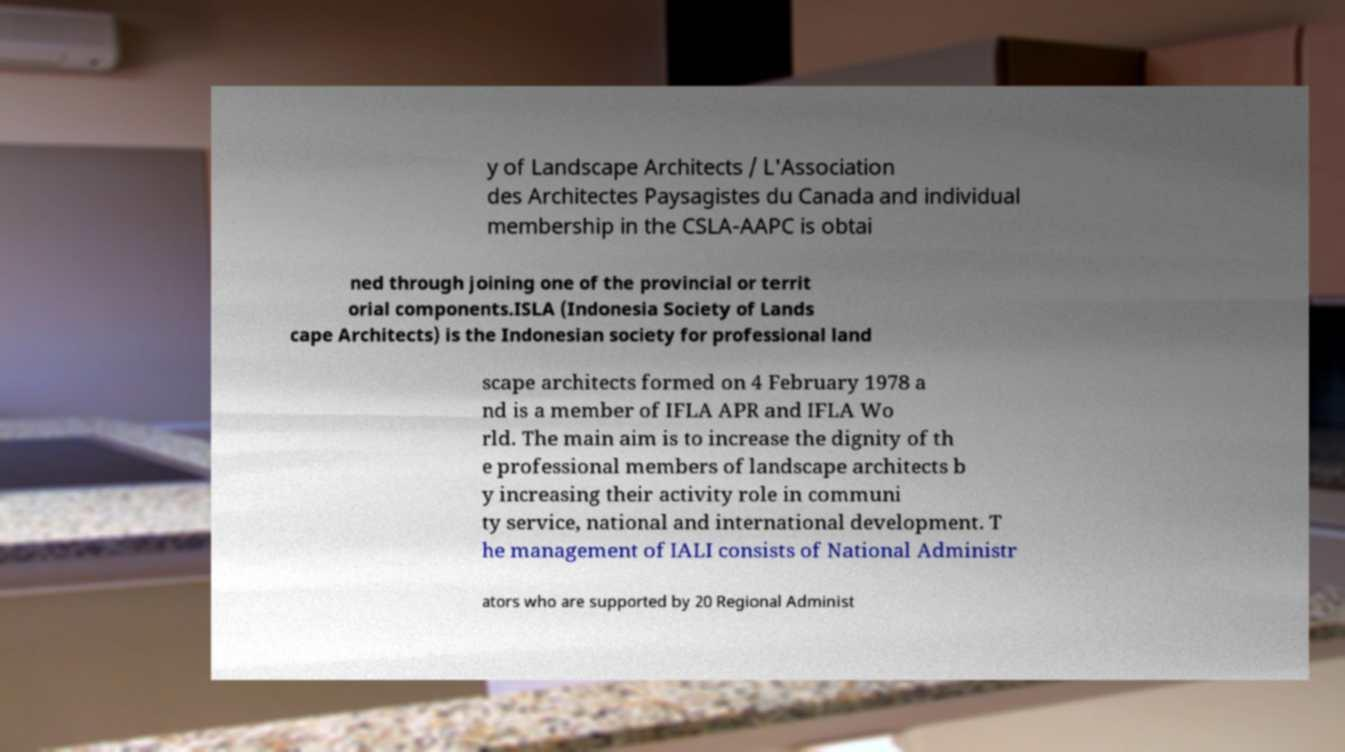Can you read and provide the text displayed in the image?This photo seems to have some interesting text. Can you extract and type it out for me? y of Landscape Architects / L'Association des Architectes Paysagistes du Canada and individual membership in the CSLA-AAPC is obtai ned through joining one of the provincial or territ orial components.ISLA (Indonesia Society of Lands cape Architects) is the Indonesian society for professional land scape architects formed on 4 February 1978 a nd is a member of IFLA APR and IFLA Wo rld. The main aim is to increase the dignity of th e professional members of landscape architects b y increasing their activity role in communi ty service, national and international development. T he management of IALI consists of National Administr ators who are supported by 20 Regional Administ 